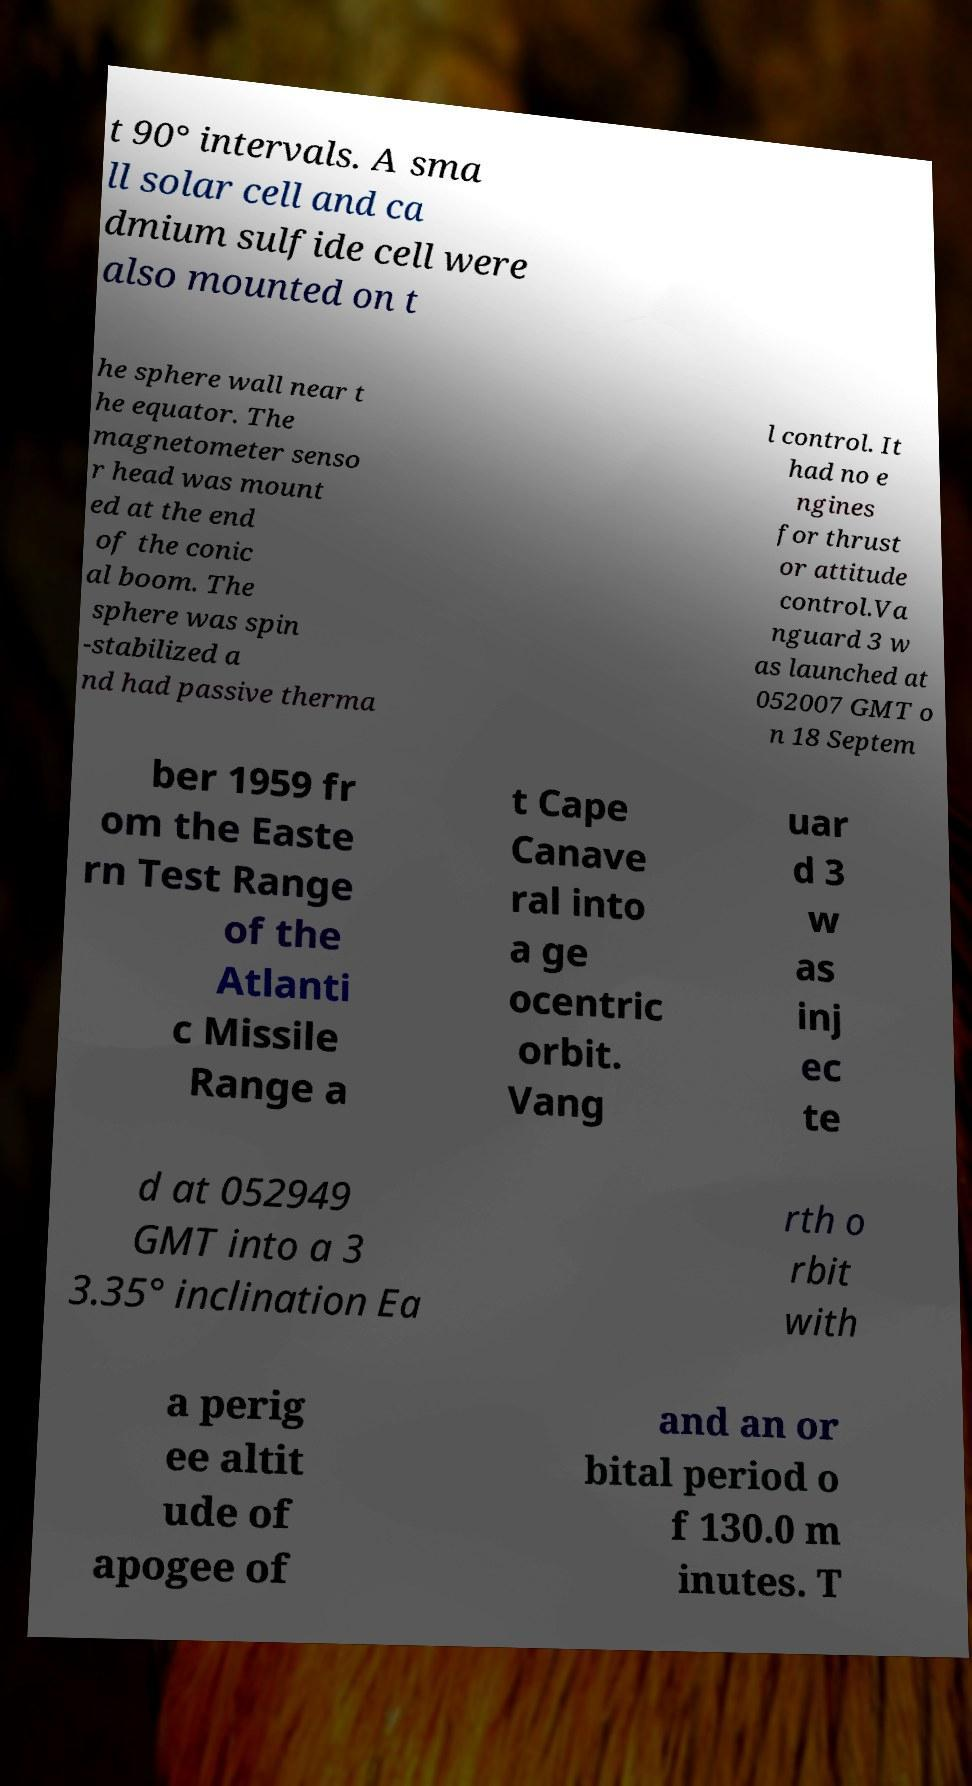Please read and relay the text visible in this image. What does it say? t 90° intervals. A sma ll solar cell and ca dmium sulfide cell were also mounted on t he sphere wall near t he equator. The magnetometer senso r head was mount ed at the end of the conic al boom. The sphere was spin -stabilized a nd had passive therma l control. It had no e ngines for thrust or attitude control.Va nguard 3 w as launched at 052007 GMT o n 18 Septem ber 1959 fr om the Easte rn Test Range of the Atlanti c Missile Range a t Cape Canave ral into a ge ocentric orbit. Vang uar d 3 w as inj ec te d at 052949 GMT into a 3 3.35° inclination Ea rth o rbit with a perig ee altit ude of apogee of and an or bital period o f 130.0 m inutes. T 